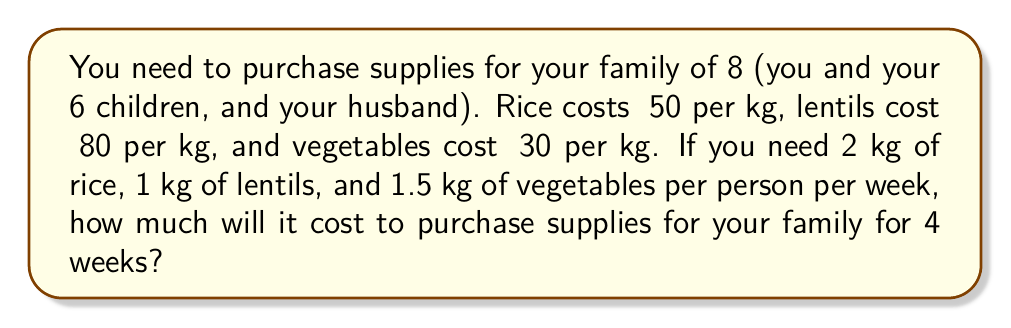Teach me how to tackle this problem. Let's break this down step-by-step:

1. Calculate the weekly requirements for each item:
   Rice: $8 \text{ people} \times 2 \text{ kg} = 16 \text{ kg}$
   Lentils: $8 \text{ people} \times 1 \text{ kg} = 8 \text{ kg}$
   Vegetables: $8 \text{ people} \times 1.5 \text{ kg} = 12 \text{ kg}$

2. Calculate the cost for each item per week:
   Rice: $16 \text{ kg} \times ₹50 = ₹800$
   Lentils: $8 \text{ kg} \times ₹80 = ₹640$
   Vegetables: $12 \text{ kg} \times ₹30 = ₹360$

3. Calculate the total cost per week:
   $₹800 + ₹640 + ₹360 = ₹1800$

4. Calculate the cost for 4 weeks:
   $₹1800 \times 4 = ₹7200$

Therefore, the cost of purchasing supplies for your family for 4 weeks is ₹7200.
Answer: ₹7200 